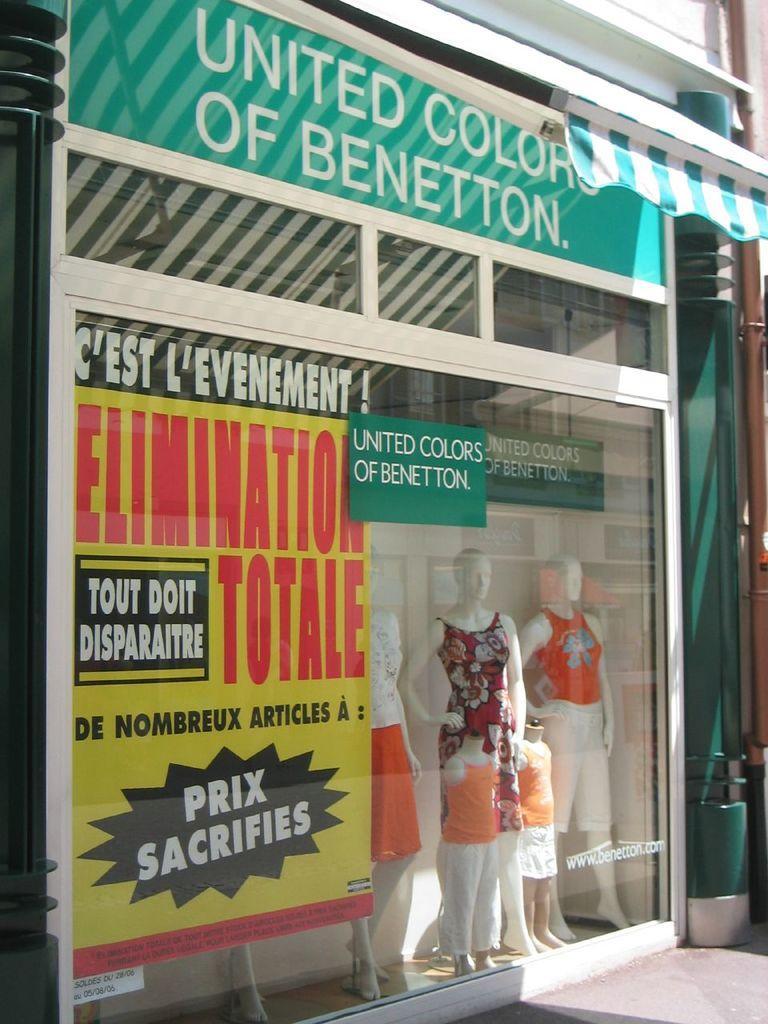How would you summarize this image in a sentence or two? In this image we can see a store, poster, boards, glass doors, clothes to the mannequins and we can see other objects. 